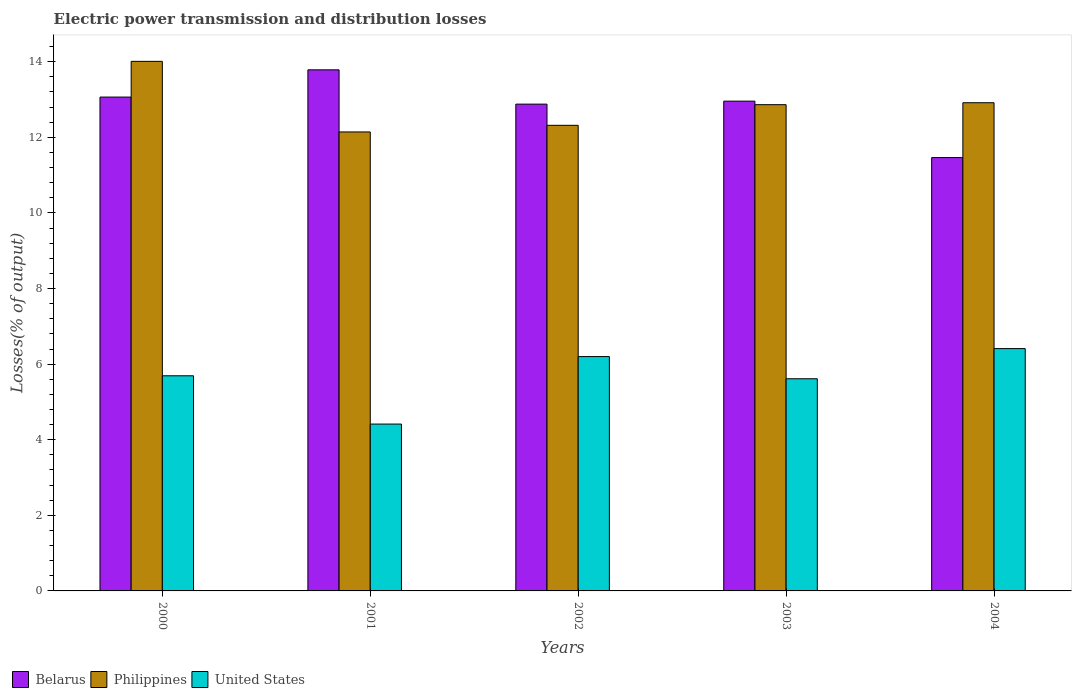Are the number of bars per tick equal to the number of legend labels?
Offer a terse response. Yes. Are the number of bars on each tick of the X-axis equal?
Your answer should be compact. Yes. How many bars are there on the 2nd tick from the right?
Ensure brevity in your answer.  3. In how many cases, is the number of bars for a given year not equal to the number of legend labels?
Give a very brief answer. 0. What is the electric power transmission and distribution losses in United States in 2000?
Provide a short and direct response. 5.69. Across all years, what is the maximum electric power transmission and distribution losses in Belarus?
Keep it short and to the point. 13.79. Across all years, what is the minimum electric power transmission and distribution losses in Belarus?
Offer a terse response. 11.46. In which year was the electric power transmission and distribution losses in Philippines minimum?
Offer a terse response. 2001. What is the total electric power transmission and distribution losses in Philippines in the graph?
Make the answer very short. 64.25. What is the difference between the electric power transmission and distribution losses in United States in 2002 and that in 2003?
Your answer should be very brief. 0.59. What is the difference between the electric power transmission and distribution losses in Belarus in 2000 and the electric power transmission and distribution losses in United States in 2002?
Provide a succinct answer. 6.87. What is the average electric power transmission and distribution losses in Belarus per year?
Make the answer very short. 12.83. In the year 2000, what is the difference between the electric power transmission and distribution losses in Belarus and electric power transmission and distribution losses in United States?
Provide a succinct answer. 7.37. What is the ratio of the electric power transmission and distribution losses in United States in 2000 to that in 2004?
Provide a succinct answer. 0.89. Is the electric power transmission and distribution losses in Philippines in 2002 less than that in 2003?
Make the answer very short. Yes. What is the difference between the highest and the second highest electric power transmission and distribution losses in United States?
Make the answer very short. 0.21. What is the difference between the highest and the lowest electric power transmission and distribution losses in Philippines?
Provide a short and direct response. 1.87. What does the 1st bar from the left in 2002 represents?
Your response must be concise. Belarus. How many bars are there?
Your answer should be compact. 15. Are all the bars in the graph horizontal?
Offer a very short reply. No. Are the values on the major ticks of Y-axis written in scientific E-notation?
Your answer should be compact. No. Does the graph contain grids?
Offer a very short reply. No. How are the legend labels stacked?
Keep it short and to the point. Horizontal. What is the title of the graph?
Give a very brief answer. Electric power transmission and distribution losses. Does "Middle income" appear as one of the legend labels in the graph?
Provide a short and direct response. No. What is the label or title of the Y-axis?
Offer a terse response. Losses(% of output). What is the Losses(% of output) in Belarus in 2000?
Ensure brevity in your answer.  13.06. What is the Losses(% of output) of Philippines in 2000?
Make the answer very short. 14.01. What is the Losses(% of output) in United States in 2000?
Your answer should be very brief. 5.69. What is the Losses(% of output) in Belarus in 2001?
Give a very brief answer. 13.79. What is the Losses(% of output) in Philippines in 2001?
Ensure brevity in your answer.  12.14. What is the Losses(% of output) of United States in 2001?
Your response must be concise. 4.41. What is the Losses(% of output) in Belarus in 2002?
Ensure brevity in your answer.  12.88. What is the Losses(% of output) in Philippines in 2002?
Keep it short and to the point. 12.32. What is the Losses(% of output) of United States in 2002?
Ensure brevity in your answer.  6.2. What is the Losses(% of output) of Belarus in 2003?
Ensure brevity in your answer.  12.96. What is the Losses(% of output) in Philippines in 2003?
Offer a terse response. 12.86. What is the Losses(% of output) in United States in 2003?
Provide a short and direct response. 5.61. What is the Losses(% of output) of Belarus in 2004?
Make the answer very short. 11.46. What is the Losses(% of output) in Philippines in 2004?
Make the answer very short. 12.92. What is the Losses(% of output) of United States in 2004?
Provide a succinct answer. 6.41. Across all years, what is the maximum Losses(% of output) of Belarus?
Your response must be concise. 13.79. Across all years, what is the maximum Losses(% of output) of Philippines?
Give a very brief answer. 14.01. Across all years, what is the maximum Losses(% of output) of United States?
Provide a succinct answer. 6.41. Across all years, what is the minimum Losses(% of output) in Belarus?
Give a very brief answer. 11.46. Across all years, what is the minimum Losses(% of output) in Philippines?
Offer a very short reply. 12.14. Across all years, what is the minimum Losses(% of output) in United States?
Provide a succinct answer. 4.41. What is the total Losses(% of output) in Belarus in the graph?
Make the answer very short. 64.15. What is the total Losses(% of output) in Philippines in the graph?
Keep it short and to the point. 64.25. What is the total Losses(% of output) of United States in the graph?
Your answer should be compact. 28.33. What is the difference between the Losses(% of output) in Belarus in 2000 and that in 2001?
Provide a short and direct response. -0.72. What is the difference between the Losses(% of output) of Philippines in 2000 and that in 2001?
Provide a succinct answer. 1.87. What is the difference between the Losses(% of output) in United States in 2000 and that in 2001?
Give a very brief answer. 1.28. What is the difference between the Losses(% of output) in Belarus in 2000 and that in 2002?
Your answer should be compact. 0.19. What is the difference between the Losses(% of output) of Philippines in 2000 and that in 2002?
Provide a succinct answer. 1.69. What is the difference between the Losses(% of output) of United States in 2000 and that in 2002?
Provide a short and direct response. -0.51. What is the difference between the Losses(% of output) in Belarus in 2000 and that in 2003?
Ensure brevity in your answer.  0.11. What is the difference between the Losses(% of output) of Philippines in 2000 and that in 2003?
Make the answer very short. 1.15. What is the difference between the Losses(% of output) in United States in 2000 and that in 2003?
Offer a terse response. 0.08. What is the difference between the Losses(% of output) in Belarus in 2000 and that in 2004?
Your answer should be very brief. 1.6. What is the difference between the Losses(% of output) of Philippines in 2000 and that in 2004?
Keep it short and to the point. 1.09. What is the difference between the Losses(% of output) in United States in 2000 and that in 2004?
Ensure brevity in your answer.  -0.72. What is the difference between the Losses(% of output) in Belarus in 2001 and that in 2002?
Your answer should be very brief. 0.91. What is the difference between the Losses(% of output) in Philippines in 2001 and that in 2002?
Provide a succinct answer. -0.18. What is the difference between the Losses(% of output) of United States in 2001 and that in 2002?
Offer a terse response. -1.79. What is the difference between the Losses(% of output) of Belarus in 2001 and that in 2003?
Offer a terse response. 0.83. What is the difference between the Losses(% of output) of Philippines in 2001 and that in 2003?
Provide a short and direct response. -0.72. What is the difference between the Losses(% of output) of United States in 2001 and that in 2003?
Keep it short and to the point. -1.2. What is the difference between the Losses(% of output) in Belarus in 2001 and that in 2004?
Make the answer very short. 2.32. What is the difference between the Losses(% of output) in Philippines in 2001 and that in 2004?
Your answer should be very brief. -0.77. What is the difference between the Losses(% of output) in United States in 2001 and that in 2004?
Give a very brief answer. -2. What is the difference between the Losses(% of output) of Belarus in 2002 and that in 2003?
Your answer should be compact. -0.08. What is the difference between the Losses(% of output) in Philippines in 2002 and that in 2003?
Provide a short and direct response. -0.55. What is the difference between the Losses(% of output) in United States in 2002 and that in 2003?
Make the answer very short. 0.59. What is the difference between the Losses(% of output) of Belarus in 2002 and that in 2004?
Ensure brevity in your answer.  1.41. What is the difference between the Losses(% of output) in Philippines in 2002 and that in 2004?
Your answer should be compact. -0.6. What is the difference between the Losses(% of output) of United States in 2002 and that in 2004?
Give a very brief answer. -0.21. What is the difference between the Losses(% of output) in Belarus in 2003 and that in 2004?
Provide a succinct answer. 1.49. What is the difference between the Losses(% of output) of Philippines in 2003 and that in 2004?
Your answer should be compact. -0.05. What is the difference between the Losses(% of output) of United States in 2003 and that in 2004?
Provide a succinct answer. -0.8. What is the difference between the Losses(% of output) in Belarus in 2000 and the Losses(% of output) in Philippines in 2001?
Ensure brevity in your answer.  0.92. What is the difference between the Losses(% of output) in Belarus in 2000 and the Losses(% of output) in United States in 2001?
Your answer should be compact. 8.65. What is the difference between the Losses(% of output) of Philippines in 2000 and the Losses(% of output) of United States in 2001?
Ensure brevity in your answer.  9.6. What is the difference between the Losses(% of output) of Belarus in 2000 and the Losses(% of output) of Philippines in 2002?
Your answer should be very brief. 0.75. What is the difference between the Losses(% of output) in Belarus in 2000 and the Losses(% of output) in United States in 2002?
Keep it short and to the point. 6.87. What is the difference between the Losses(% of output) in Philippines in 2000 and the Losses(% of output) in United States in 2002?
Provide a short and direct response. 7.81. What is the difference between the Losses(% of output) of Belarus in 2000 and the Losses(% of output) of Philippines in 2003?
Offer a terse response. 0.2. What is the difference between the Losses(% of output) in Belarus in 2000 and the Losses(% of output) in United States in 2003?
Provide a succinct answer. 7.45. What is the difference between the Losses(% of output) in Philippines in 2000 and the Losses(% of output) in United States in 2003?
Make the answer very short. 8.4. What is the difference between the Losses(% of output) in Belarus in 2000 and the Losses(% of output) in Philippines in 2004?
Your response must be concise. 0.15. What is the difference between the Losses(% of output) of Belarus in 2000 and the Losses(% of output) of United States in 2004?
Offer a very short reply. 6.65. What is the difference between the Losses(% of output) of Philippines in 2000 and the Losses(% of output) of United States in 2004?
Your answer should be very brief. 7.6. What is the difference between the Losses(% of output) of Belarus in 2001 and the Losses(% of output) of Philippines in 2002?
Give a very brief answer. 1.47. What is the difference between the Losses(% of output) of Belarus in 2001 and the Losses(% of output) of United States in 2002?
Provide a short and direct response. 7.59. What is the difference between the Losses(% of output) in Philippines in 2001 and the Losses(% of output) in United States in 2002?
Make the answer very short. 5.94. What is the difference between the Losses(% of output) in Belarus in 2001 and the Losses(% of output) in Philippines in 2003?
Your response must be concise. 0.92. What is the difference between the Losses(% of output) in Belarus in 2001 and the Losses(% of output) in United States in 2003?
Your response must be concise. 8.17. What is the difference between the Losses(% of output) in Philippines in 2001 and the Losses(% of output) in United States in 2003?
Your answer should be very brief. 6.53. What is the difference between the Losses(% of output) in Belarus in 2001 and the Losses(% of output) in Philippines in 2004?
Offer a terse response. 0.87. What is the difference between the Losses(% of output) of Belarus in 2001 and the Losses(% of output) of United States in 2004?
Make the answer very short. 7.37. What is the difference between the Losses(% of output) in Philippines in 2001 and the Losses(% of output) in United States in 2004?
Offer a terse response. 5.73. What is the difference between the Losses(% of output) of Belarus in 2002 and the Losses(% of output) of Philippines in 2003?
Offer a terse response. 0.01. What is the difference between the Losses(% of output) of Belarus in 2002 and the Losses(% of output) of United States in 2003?
Give a very brief answer. 7.27. What is the difference between the Losses(% of output) in Philippines in 2002 and the Losses(% of output) in United States in 2003?
Your response must be concise. 6.71. What is the difference between the Losses(% of output) of Belarus in 2002 and the Losses(% of output) of Philippines in 2004?
Provide a succinct answer. -0.04. What is the difference between the Losses(% of output) of Belarus in 2002 and the Losses(% of output) of United States in 2004?
Give a very brief answer. 6.47. What is the difference between the Losses(% of output) of Philippines in 2002 and the Losses(% of output) of United States in 2004?
Make the answer very short. 5.91. What is the difference between the Losses(% of output) in Belarus in 2003 and the Losses(% of output) in Philippines in 2004?
Offer a terse response. 0.04. What is the difference between the Losses(% of output) of Belarus in 2003 and the Losses(% of output) of United States in 2004?
Give a very brief answer. 6.55. What is the difference between the Losses(% of output) of Philippines in 2003 and the Losses(% of output) of United States in 2004?
Offer a very short reply. 6.45. What is the average Losses(% of output) of Belarus per year?
Offer a terse response. 12.83. What is the average Losses(% of output) in Philippines per year?
Ensure brevity in your answer.  12.85. What is the average Losses(% of output) in United States per year?
Your answer should be compact. 5.67. In the year 2000, what is the difference between the Losses(% of output) in Belarus and Losses(% of output) in Philippines?
Keep it short and to the point. -0.95. In the year 2000, what is the difference between the Losses(% of output) of Belarus and Losses(% of output) of United States?
Offer a terse response. 7.37. In the year 2000, what is the difference between the Losses(% of output) in Philippines and Losses(% of output) in United States?
Your response must be concise. 8.32. In the year 2001, what is the difference between the Losses(% of output) of Belarus and Losses(% of output) of Philippines?
Offer a very short reply. 1.64. In the year 2001, what is the difference between the Losses(% of output) of Belarus and Losses(% of output) of United States?
Keep it short and to the point. 9.37. In the year 2001, what is the difference between the Losses(% of output) of Philippines and Losses(% of output) of United States?
Make the answer very short. 7.73. In the year 2002, what is the difference between the Losses(% of output) of Belarus and Losses(% of output) of Philippines?
Your answer should be compact. 0.56. In the year 2002, what is the difference between the Losses(% of output) of Belarus and Losses(% of output) of United States?
Keep it short and to the point. 6.68. In the year 2002, what is the difference between the Losses(% of output) of Philippines and Losses(% of output) of United States?
Your answer should be compact. 6.12. In the year 2003, what is the difference between the Losses(% of output) of Belarus and Losses(% of output) of Philippines?
Offer a terse response. 0.09. In the year 2003, what is the difference between the Losses(% of output) in Belarus and Losses(% of output) in United States?
Your answer should be compact. 7.34. In the year 2003, what is the difference between the Losses(% of output) of Philippines and Losses(% of output) of United States?
Offer a terse response. 7.25. In the year 2004, what is the difference between the Losses(% of output) of Belarus and Losses(% of output) of Philippines?
Your answer should be compact. -1.45. In the year 2004, what is the difference between the Losses(% of output) in Belarus and Losses(% of output) in United States?
Offer a very short reply. 5.05. In the year 2004, what is the difference between the Losses(% of output) of Philippines and Losses(% of output) of United States?
Keep it short and to the point. 6.5. What is the ratio of the Losses(% of output) of Belarus in 2000 to that in 2001?
Give a very brief answer. 0.95. What is the ratio of the Losses(% of output) in Philippines in 2000 to that in 2001?
Keep it short and to the point. 1.15. What is the ratio of the Losses(% of output) of United States in 2000 to that in 2001?
Make the answer very short. 1.29. What is the ratio of the Losses(% of output) in Belarus in 2000 to that in 2002?
Ensure brevity in your answer.  1.01. What is the ratio of the Losses(% of output) in Philippines in 2000 to that in 2002?
Your answer should be compact. 1.14. What is the ratio of the Losses(% of output) of United States in 2000 to that in 2002?
Your answer should be compact. 0.92. What is the ratio of the Losses(% of output) in Belarus in 2000 to that in 2003?
Your response must be concise. 1.01. What is the ratio of the Losses(% of output) of Philippines in 2000 to that in 2003?
Offer a very short reply. 1.09. What is the ratio of the Losses(% of output) in United States in 2000 to that in 2003?
Make the answer very short. 1.01. What is the ratio of the Losses(% of output) in Belarus in 2000 to that in 2004?
Offer a very short reply. 1.14. What is the ratio of the Losses(% of output) of Philippines in 2000 to that in 2004?
Keep it short and to the point. 1.08. What is the ratio of the Losses(% of output) of United States in 2000 to that in 2004?
Provide a short and direct response. 0.89. What is the ratio of the Losses(% of output) of Belarus in 2001 to that in 2002?
Your answer should be compact. 1.07. What is the ratio of the Losses(% of output) of Philippines in 2001 to that in 2002?
Your response must be concise. 0.99. What is the ratio of the Losses(% of output) in United States in 2001 to that in 2002?
Ensure brevity in your answer.  0.71. What is the ratio of the Losses(% of output) of Belarus in 2001 to that in 2003?
Provide a short and direct response. 1.06. What is the ratio of the Losses(% of output) in Philippines in 2001 to that in 2003?
Your response must be concise. 0.94. What is the ratio of the Losses(% of output) in United States in 2001 to that in 2003?
Make the answer very short. 0.79. What is the ratio of the Losses(% of output) in Belarus in 2001 to that in 2004?
Your answer should be very brief. 1.2. What is the ratio of the Losses(% of output) of Philippines in 2001 to that in 2004?
Offer a terse response. 0.94. What is the ratio of the Losses(% of output) in United States in 2001 to that in 2004?
Offer a terse response. 0.69. What is the ratio of the Losses(% of output) in Belarus in 2002 to that in 2003?
Your answer should be compact. 0.99. What is the ratio of the Losses(% of output) in Philippines in 2002 to that in 2003?
Make the answer very short. 0.96. What is the ratio of the Losses(% of output) in United States in 2002 to that in 2003?
Your response must be concise. 1.1. What is the ratio of the Losses(% of output) of Belarus in 2002 to that in 2004?
Offer a terse response. 1.12. What is the ratio of the Losses(% of output) of Philippines in 2002 to that in 2004?
Give a very brief answer. 0.95. What is the ratio of the Losses(% of output) in United States in 2002 to that in 2004?
Keep it short and to the point. 0.97. What is the ratio of the Losses(% of output) in Belarus in 2003 to that in 2004?
Provide a succinct answer. 1.13. What is the ratio of the Losses(% of output) of United States in 2003 to that in 2004?
Provide a succinct answer. 0.88. What is the difference between the highest and the second highest Losses(% of output) in Belarus?
Your answer should be compact. 0.72. What is the difference between the highest and the second highest Losses(% of output) of Philippines?
Give a very brief answer. 1.09. What is the difference between the highest and the second highest Losses(% of output) in United States?
Make the answer very short. 0.21. What is the difference between the highest and the lowest Losses(% of output) in Belarus?
Your answer should be compact. 2.32. What is the difference between the highest and the lowest Losses(% of output) of Philippines?
Offer a very short reply. 1.87. What is the difference between the highest and the lowest Losses(% of output) in United States?
Keep it short and to the point. 2. 